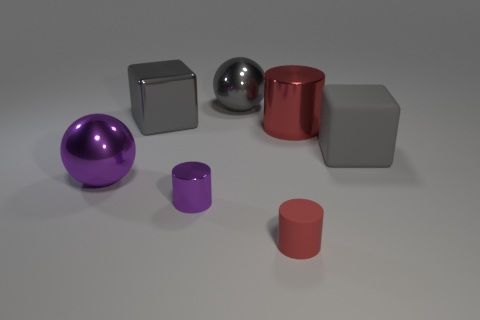What color is the metal cylinder on the right side of the red cylinder in front of the metallic cylinder to the right of the gray ball?
Offer a very short reply. Red. Are there fewer tiny shiny objects in front of the gray shiny ball than gray objects that are on the left side of the gray matte object?
Provide a short and direct response. Yes. Is the shape of the tiny rubber thing the same as the small purple thing?
Your answer should be very brief. Yes. What number of other cylinders are the same size as the purple metallic cylinder?
Make the answer very short. 1. Is the number of metallic balls that are on the left side of the big purple metal ball less than the number of small cylinders?
Offer a terse response. Yes. There is a rubber cylinder right of the cube on the left side of the small purple metal cylinder; what is its size?
Keep it short and to the point. Small. What number of objects are either big red shiny cylinders or matte blocks?
Ensure brevity in your answer.  2. Are there any things of the same color as the metallic block?
Give a very brief answer. Yes. Is the number of large red things less than the number of tiny gray metallic things?
Keep it short and to the point. No. How many objects are either yellow rubber objects or small things that are to the right of the gray shiny sphere?
Your answer should be compact. 1. 